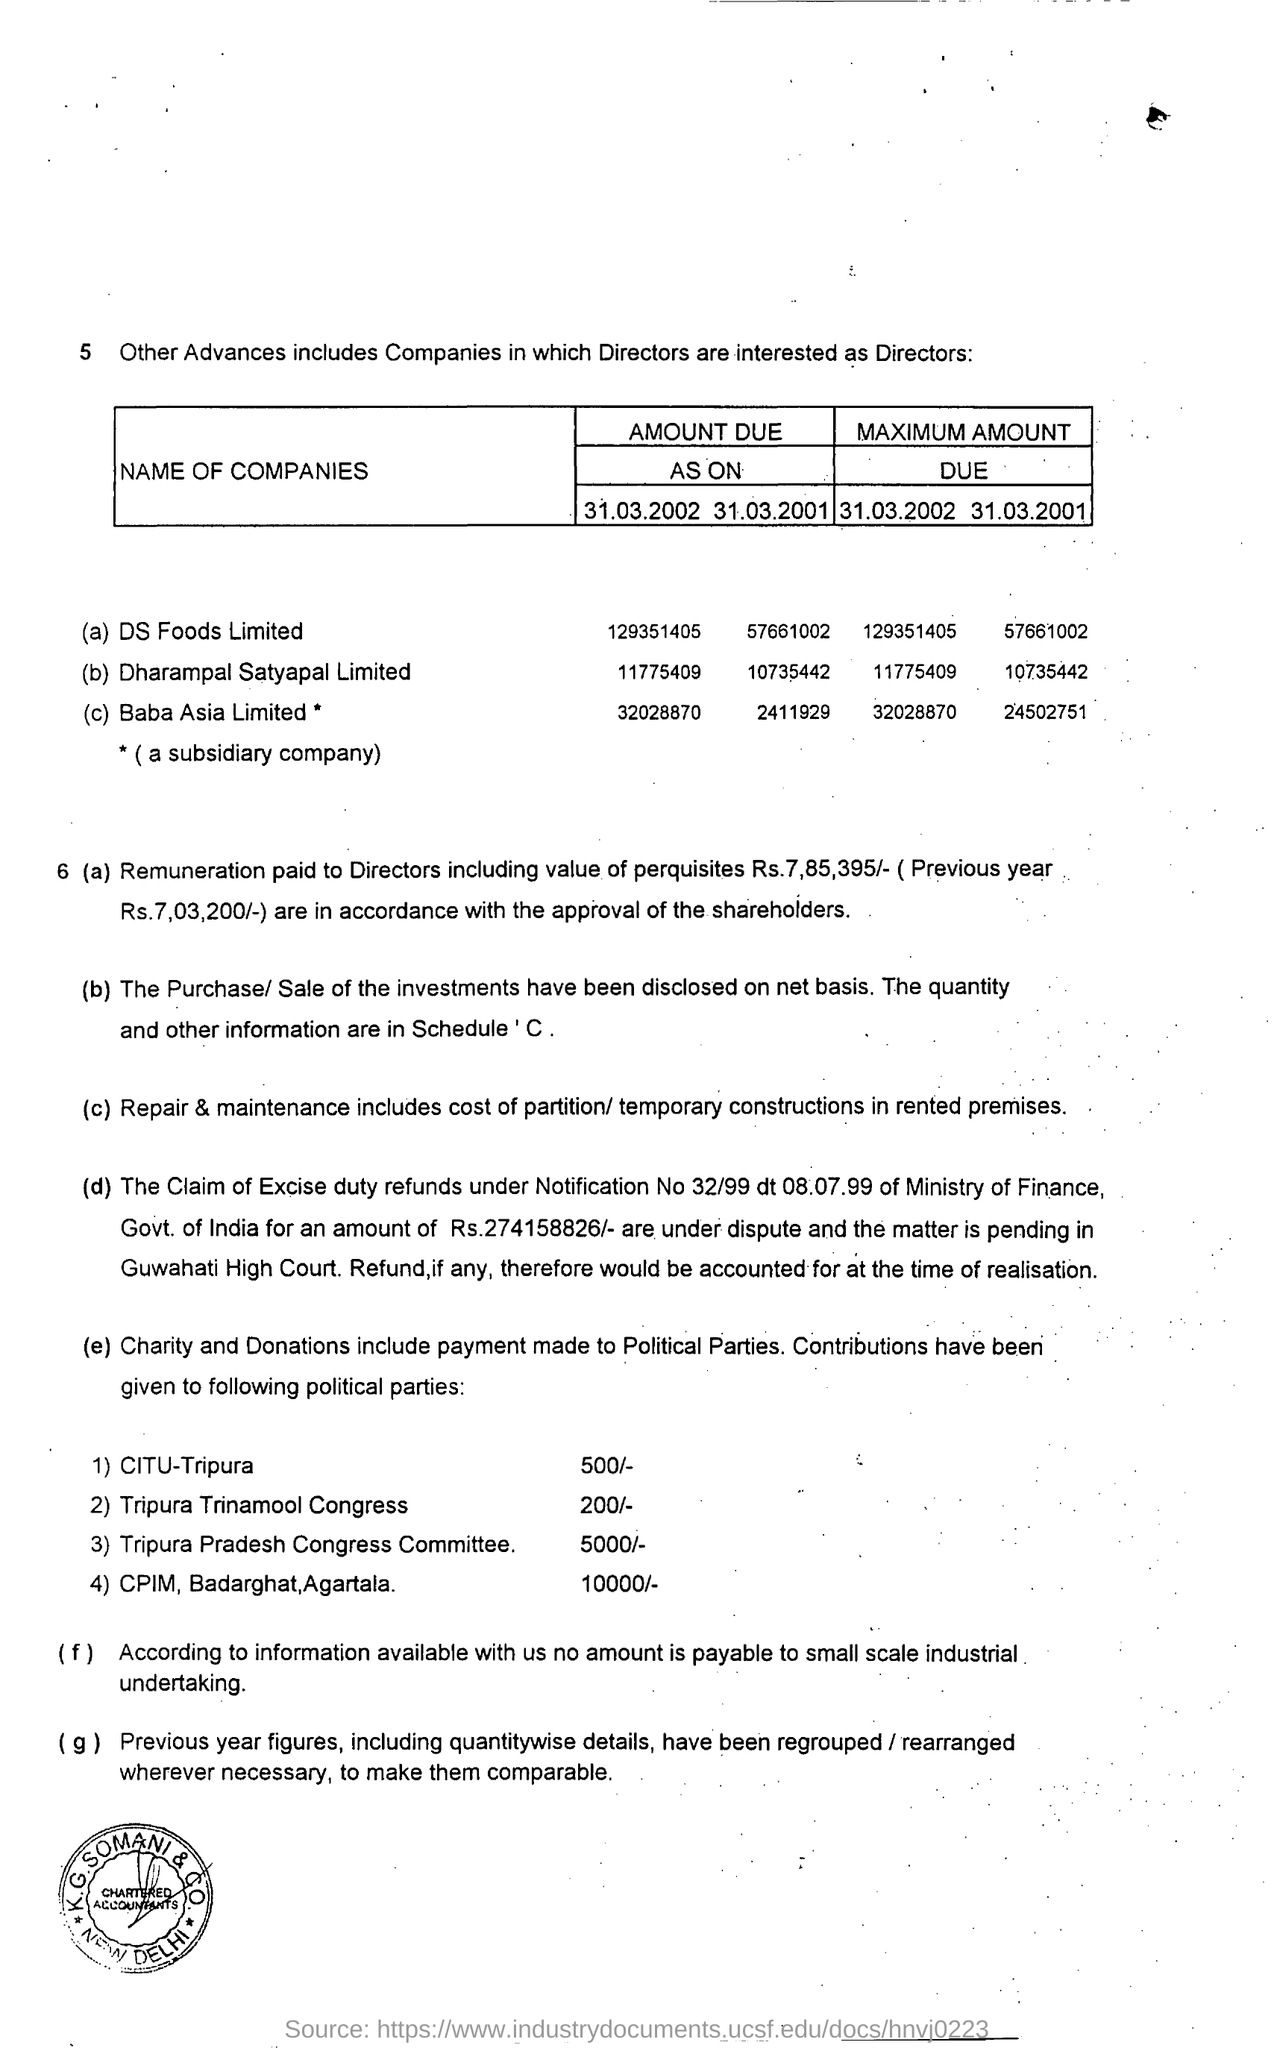How much amount of remuneration paid to the directors including value of perquisites ?
Your response must be concise. Rs. 7,85,395/-. How much amount is due as on 31.0..2002 for the ds foods limited ?
Keep it short and to the point. 129351405. How much amount is contributed to tripura trinamool congress?
Your answer should be compact. 200. How much amount is contributed to citu-tripura ?
Offer a very short reply. 500/-. How much amount is contributed to tripura pradesh congress committee?
Your response must be concise. 5000/-. 